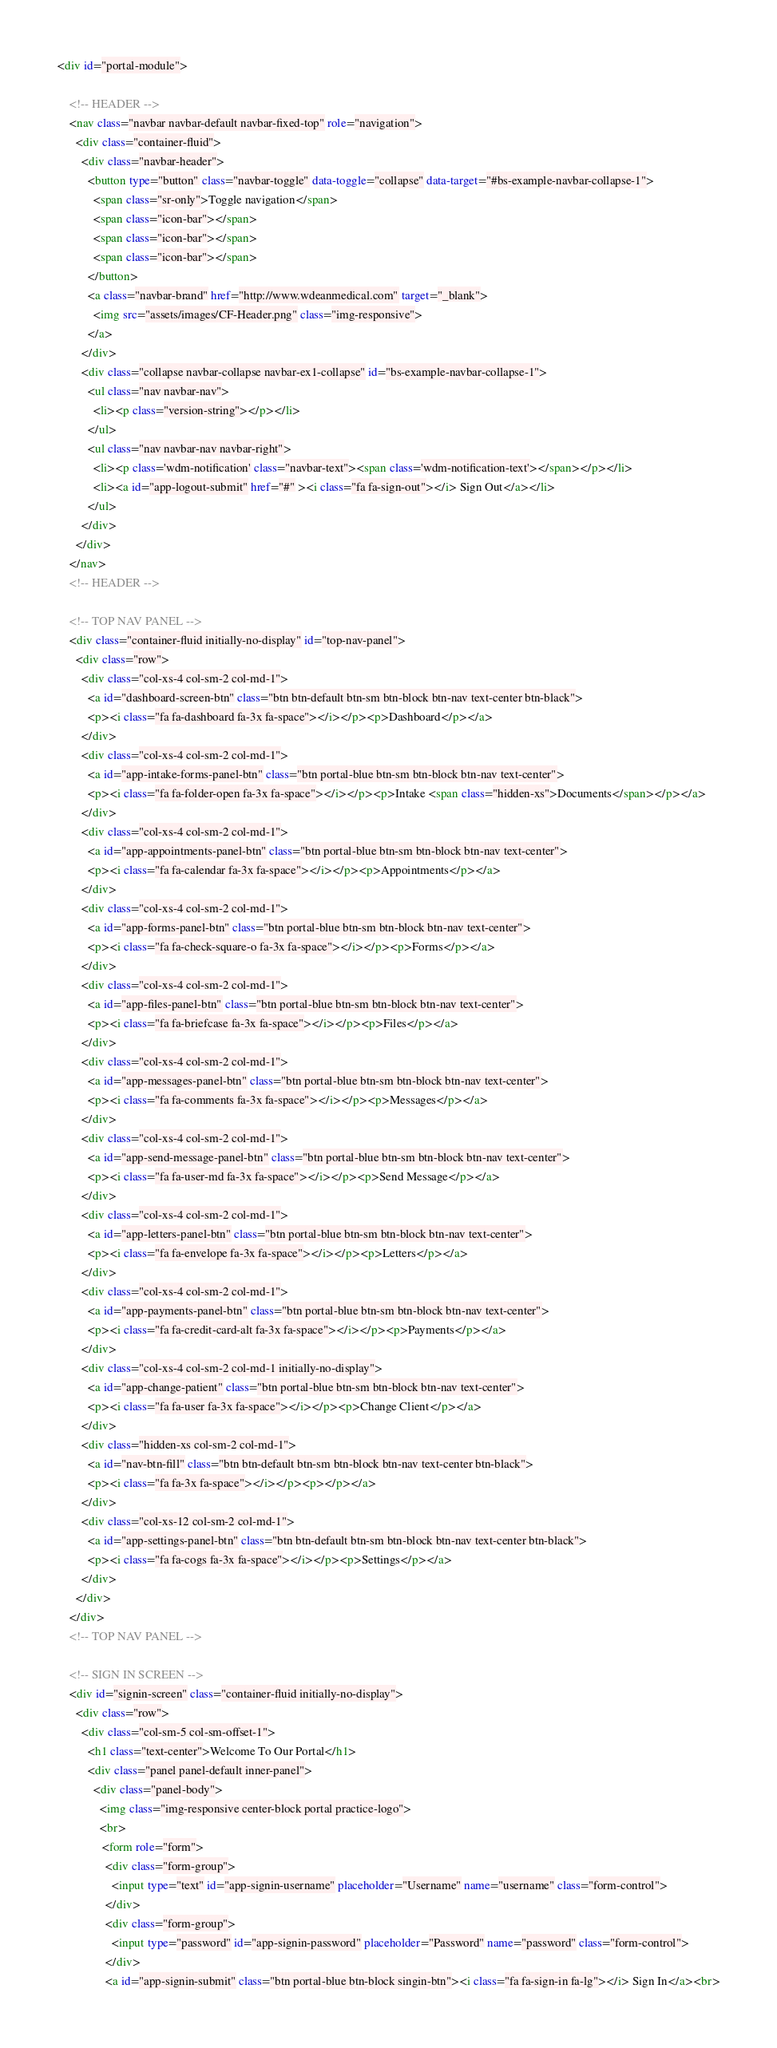<code> <loc_0><loc_0><loc_500><loc_500><_HTML_><div id="portal-module">

    <!-- HEADER --> 
    <nav class="navbar navbar-default navbar-fixed-top" role="navigation">
      <div class="container-fluid">
        <div class="navbar-header">
          <button type="button" class="navbar-toggle" data-toggle="collapse" data-target="#bs-example-navbar-collapse-1">
            <span class="sr-only">Toggle navigation</span>
            <span class="icon-bar"></span>
            <span class="icon-bar"></span>
            <span class="icon-bar"></span>
          </button>
          <a class="navbar-brand" href="http://www.wdeanmedical.com" target="_blank">
            <img src="assets/images/CF-Header.png" class="img-responsive">
          </a>
        </div>
        <div class="collapse navbar-collapse navbar-ex1-collapse" id="bs-example-navbar-collapse-1">
          <ul class="nav navbar-nav">
            <li><p class="version-string"></p></li>
          </ul>
          <ul class="nav navbar-nav navbar-right">
            <li><p class='wdm-notification' class="navbar-text"><span class='wdm-notification-text'></span></p></li>
            <li><a id="app-logout-submit" href="#" ><i class="fa fa-sign-out"></i> Sign Out</a></li>
          </ul>
        </div>
      </div>
    </nav>
    <!-- HEADER --> 
    
    <!-- TOP NAV PANEL -->
    <div class="container-fluid initially-no-display" id="top-nav-panel">
      <div class="row">
        <div class="col-xs-4 col-sm-2 col-md-1">
          <a id="dashboard-screen-btn" class="btn btn-default btn-sm btn-block btn-nav text-center btn-black">
          <p><i class="fa fa-dashboard fa-3x fa-space"></i></p><p>Dashboard</p></a>
        </div>
        <div class="col-xs-4 col-sm-2 col-md-1">
          <a id="app-intake-forms-panel-btn" class="btn portal-blue btn-sm btn-block btn-nav text-center">
          <p><i class="fa fa-folder-open fa-3x fa-space"></i></p><p>Intake <span class="hidden-xs">Documents</span></p></a>
        </div>
        <div class="col-xs-4 col-sm-2 col-md-1">
          <a id="app-appointments-panel-btn" class="btn portal-blue btn-sm btn-block btn-nav text-center">
          <p><i class="fa fa-calendar fa-3x fa-space"></i></p><p>Appointments</p></a>
        </div>
        <div class="col-xs-4 col-sm-2 col-md-1">
          <a id="app-forms-panel-btn" class="btn portal-blue btn-sm btn-block btn-nav text-center">
          <p><i class="fa fa-check-square-o fa-3x fa-space"></i></p><p>Forms</p></a>
        </div>
        <div class="col-xs-4 col-sm-2 col-md-1">
          <a id="app-files-panel-btn" class="btn portal-blue btn-sm btn-block btn-nav text-center">
          <p><i class="fa fa-briefcase fa-3x fa-space"></i></p><p>Files</p></a>
        </div>
        <div class="col-xs-4 col-sm-2 col-md-1">
          <a id="app-messages-panel-btn" class="btn portal-blue btn-sm btn-block btn-nav text-center">
          <p><i class="fa fa-comments fa-3x fa-space"></i></p><p>Messages</p></a>
        </div>
        <div class="col-xs-4 col-sm-2 col-md-1">
          <a id="app-send-message-panel-btn" class="btn portal-blue btn-sm btn-block btn-nav text-center">
          <p><i class="fa fa-user-md fa-3x fa-space"></i></p><p>Send Message</p></a>
        </div>
        <div class="col-xs-4 col-sm-2 col-md-1">
          <a id="app-letters-panel-btn" class="btn portal-blue btn-sm btn-block btn-nav text-center">
          <p><i class="fa fa-envelope fa-3x fa-space"></i></p><p>Letters</p></a>
        </div>
        <div class="col-xs-4 col-sm-2 col-md-1">
          <a id="app-payments-panel-btn" class="btn portal-blue btn-sm btn-block btn-nav text-center">
          <p><i class="fa fa-credit-card-alt fa-3x fa-space"></i></p><p>Payments</p></a>
        </div>
        <div class="col-xs-4 col-sm-2 col-md-1 initially-no-display">
          <a id="app-change-patient" class="btn portal-blue btn-sm btn-block btn-nav text-center">
          <p><i class="fa fa-user fa-3x fa-space"></i></p><p>Change Client</p></a>
        </div>
        <div class="hidden-xs col-sm-2 col-md-1">
          <a id="nav-btn-fill" class="btn btn-default btn-sm btn-block btn-nav text-center btn-black">
          <p><i class="fa fa-3x fa-space"></i></p><p></p></a>
        </div>
        <div class="col-xs-12 col-sm-2 col-md-1">
          <a id="app-settings-panel-btn" class="btn btn-default btn-sm btn-block btn-nav text-center btn-black">
          <p><i class="fa fa-cogs fa-3x fa-space"></i></p><p>Settings</p></a>
        </div>
      </div>
    </div>
    <!-- TOP NAV PANEL -->

    <!-- SIGN IN SCREEN -->
    <div id="signin-screen" class="container-fluid initially-no-display">
      <div class="row">
        <div class="col-sm-5 col-sm-offset-1">
          <h1 class="text-center">Welcome To Our Portal</h1>
          <div class="panel panel-default inner-panel">
            <div class="panel-body">
              <img class="img-responsive center-block portal practice-logo">
              <br>
               <form role="form">
                <div class="form-group">
                  <input type="text" id="app-signin-username" placeholder="Username" name="username" class="form-control">
                </div>
                <div class="form-group">
                  <input type="password" id="app-signin-password" placeholder="Password" name="password" class="form-control">
                </div>
                <a id="app-signin-submit" class="btn portal-blue btn-block singin-btn"><i class="fa fa-sign-in fa-lg"></i> Sign In</a><br></code> 